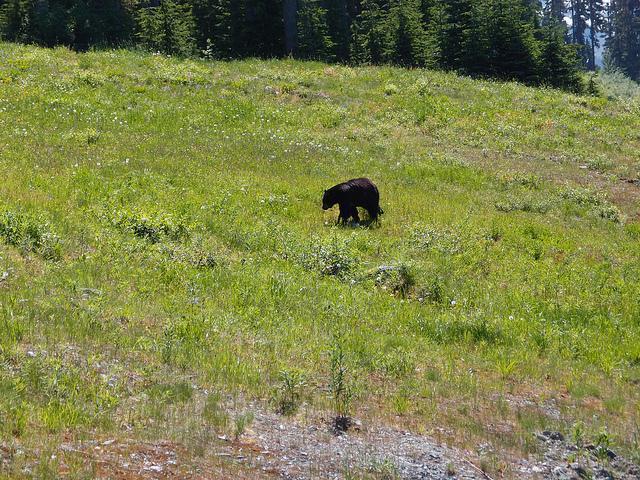How many elephants are there?
Give a very brief answer. 0. 